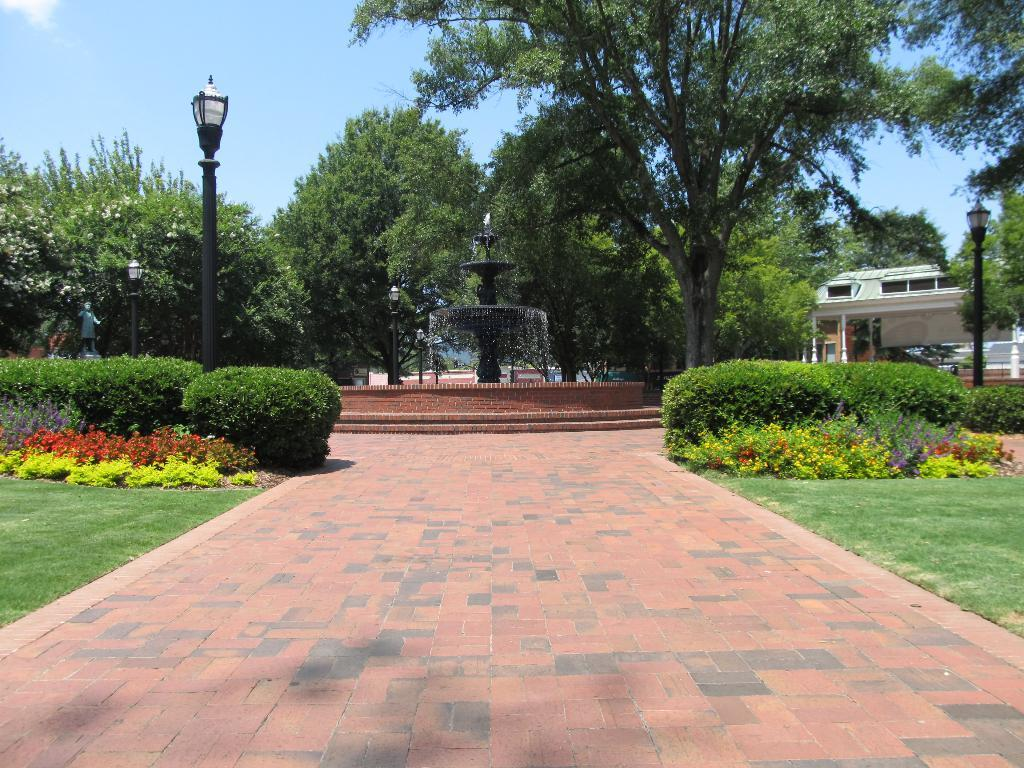What is the main feature in the image? There is a fountain in the image. What other structures can be seen in the image? There are light poles in the image. What type of vegetation is present in the image? There are trees, plants, and grass in the image. What can be seen in the background of the image? The sky is visible in the background of the image. Where is the heart-shaped flower located in the image? There is no heart-shaped flower present in the image. What type of shade is provided by the trees in the image? The trees in the image do not provide any shade, as the image does not show the sun or any shadows. 